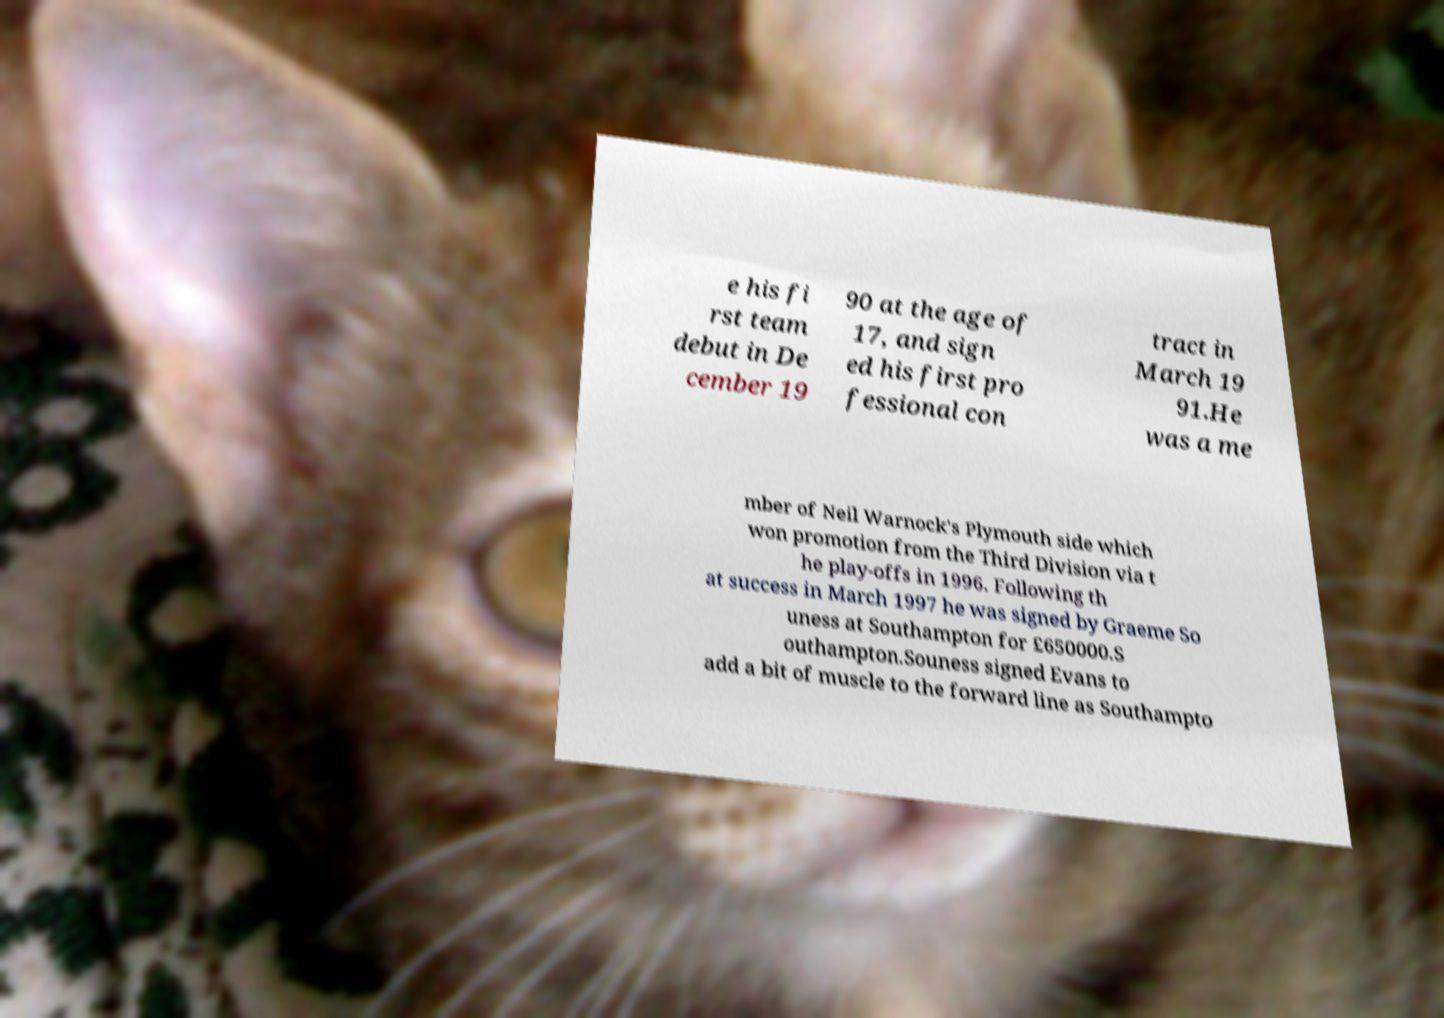Can you accurately transcribe the text from the provided image for me? e his fi rst team debut in De cember 19 90 at the age of 17, and sign ed his first pro fessional con tract in March 19 91.He was a me mber of Neil Warnock's Plymouth side which won promotion from the Third Division via t he play-offs in 1996. Following th at success in March 1997 he was signed by Graeme So uness at Southampton for £650000.S outhampton.Souness signed Evans to add a bit of muscle to the forward line as Southampto 